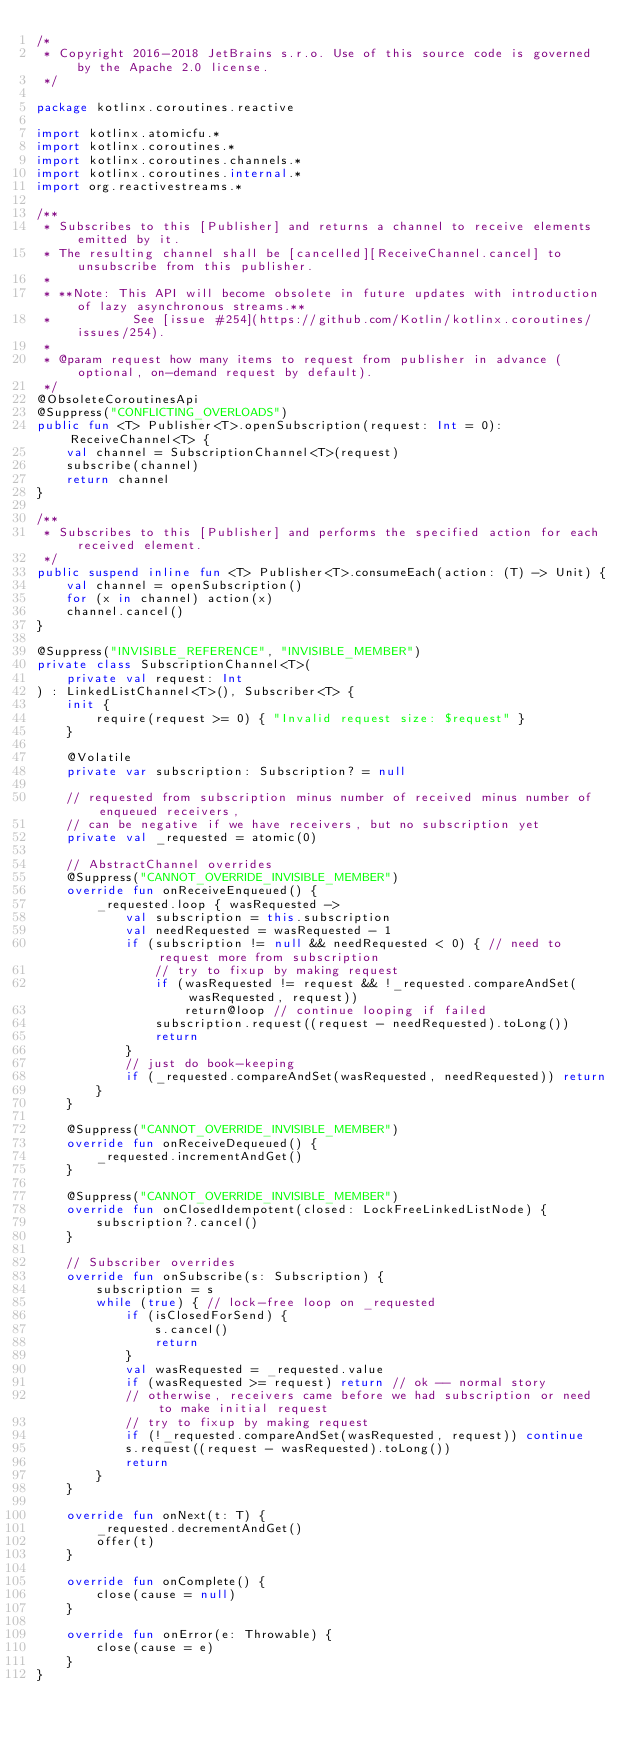Convert code to text. <code><loc_0><loc_0><loc_500><loc_500><_Kotlin_>/*
 * Copyright 2016-2018 JetBrains s.r.o. Use of this source code is governed by the Apache 2.0 license.
 */

package kotlinx.coroutines.reactive

import kotlinx.atomicfu.*
import kotlinx.coroutines.*
import kotlinx.coroutines.channels.*
import kotlinx.coroutines.internal.*
import org.reactivestreams.*

/**
 * Subscribes to this [Publisher] and returns a channel to receive elements emitted by it.
 * The resulting channel shall be [cancelled][ReceiveChannel.cancel] to unsubscribe from this publisher.
 *
 * **Note: This API will become obsolete in future updates with introduction of lazy asynchronous streams.**
 *           See [issue #254](https://github.com/Kotlin/kotlinx.coroutines/issues/254).
 *
 * @param request how many items to request from publisher in advance (optional, on-demand request by default).
 */
@ObsoleteCoroutinesApi
@Suppress("CONFLICTING_OVERLOADS")
public fun <T> Publisher<T>.openSubscription(request: Int = 0): ReceiveChannel<T> {
    val channel = SubscriptionChannel<T>(request)
    subscribe(channel)
    return channel
}

/**
 * Subscribes to this [Publisher] and performs the specified action for each received element.
 */
public suspend inline fun <T> Publisher<T>.consumeEach(action: (T) -> Unit) {
    val channel = openSubscription()
    for (x in channel) action(x)
    channel.cancel()
}

@Suppress("INVISIBLE_REFERENCE", "INVISIBLE_MEMBER")
private class SubscriptionChannel<T>(
    private val request: Int
) : LinkedListChannel<T>(), Subscriber<T> {
    init {
        require(request >= 0) { "Invalid request size: $request" }
    }

    @Volatile
    private var subscription: Subscription? = null

    // requested from subscription minus number of received minus number of enqueued receivers,
    // can be negative if we have receivers, but no subscription yet
    private val _requested = atomic(0)

    // AbstractChannel overrides
    @Suppress("CANNOT_OVERRIDE_INVISIBLE_MEMBER")
    override fun onReceiveEnqueued() {
        _requested.loop { wasRequested ->
            val subscription = this.subscription
            val needRequested = wasRequested - 1
            if (subscription != null && needRequested < 0) { // need to request more from subscription
                // try to fixup by making request
                if (wasRequested != request && !_requested.compareAndSet(wasRequested, request))
                    return@loop // continue looping if failed
                subscription.request((request - needRequested).toLong())
                return
            }
            // just do book-keeping
            if (_requested.compareAndSet(wasRequested, needRequested)) return
        }
    }

    @Suppress("CANNOT_OVERRIDE_INVISIBLE_MEMBER")
    override fun onReceiveDequeued() {
        _requested.incrementAndGet()
    }

    @Suppress("CANNOT_OVERRIDE_INVISIBLE_MEMBER")
    override fun onClosedIdempotent(closed: LockFreeLinkedListNode) {
        subscription?.cancel()
    }

    // Subscriber overrides
    override fun onSubscribe(s: Subscription) {
        subscription = s
        while (true) { // lock-free loop on _requested
            if (isClosedForSend) {
                s.cancel()
                return
            }
            val wasRequested = _requested.value
            if (wasRequested >= request) return // ok -- normal story
            // otherwise, receivers came before we had subscription or need to make initial request
            // try to fixup by making request
            if (!_requested.compareAndSet(wasRequested, request)) continue
            s.request((request - wasRequested).toLong())
            return
        }
    }

    override fun onNext(t: T) {
        _requested.decrementAndGet()
        offer(t)
    }

    override fun onComplete() {
        close(cause = null)
    }

    override fun onError(e: Throwable) {
        close(cause = e)
    }
}

</code> 